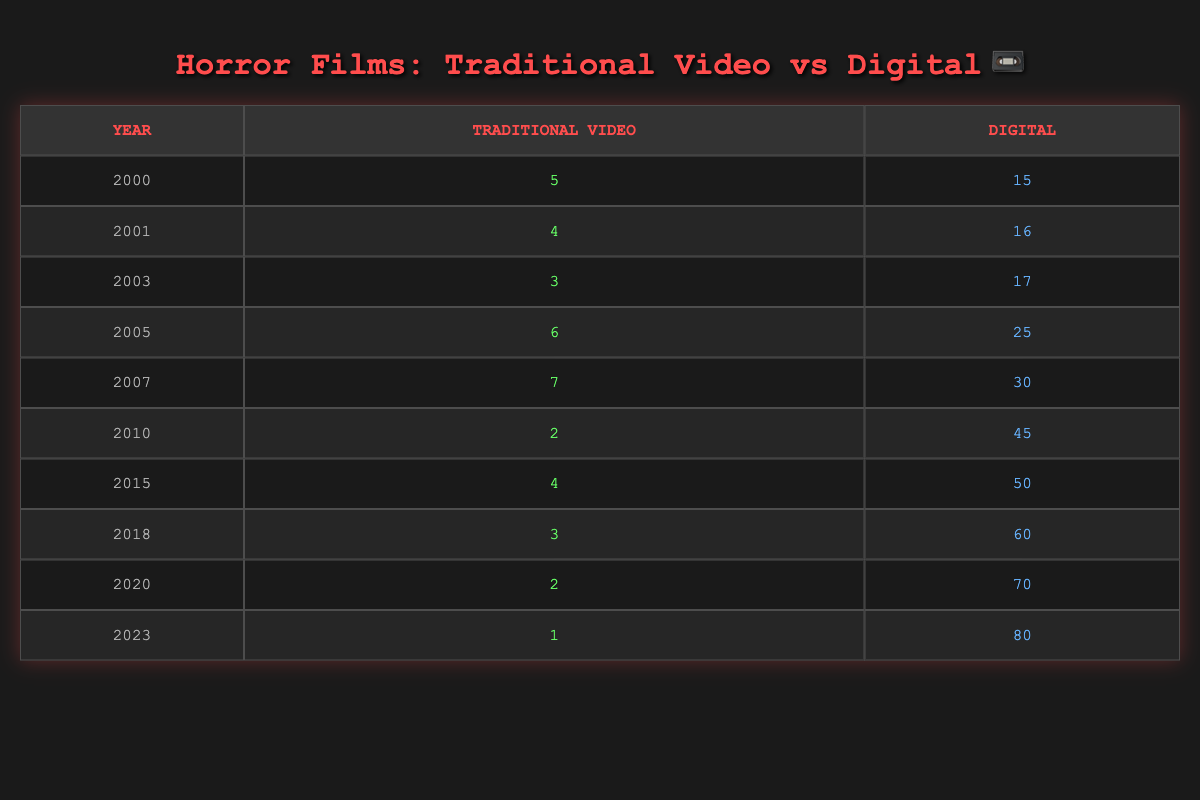What year had the highest number of traditional video horror films? Looking at the "Traditional Video" column, the highest value is 7, which occurs in the year 2007.
Answer: 2007 How many digital horror films were released in total from 2000 to 2023? To find the total, we sum the "Digital" column: 15 + 16 + 17 + 25 + 30 + 45 + 50 + 60 + 70 + 80 = 408.
Answer: 408 Was there an increase or decrease in the number of traditional video films from 2001 to 2005? In 2001, there were 4 traditional video films and in 2005, there were 6. Since 6 is greater than 4, it indicates an increase.
Answer: Increase What is the difference between the number of traditional and digital horror films in the year 2010? In 2010, there were 2 traditional video films and 45 digital films. The difference is 45 - 2 = 43.
Answer: 43 What was the average number of traditional video horror films released per year from 2000 to 2023? To find the average, we first sum the traditional video films: 5 + 4 + 3 + 6 + 7 + 2 + 4 + 3 + 2 + 1 = 37. There are 10 years, so the average is 37 / 10 = 3.7.
Answer: 3.7 Was the number of digital horror films in 2023 greater than the average for digital films from 2000 to 2023? First, we find the average for digital films: (15 + 16 + 17 + 25 + 30 + 45 + 50 + 60 + 70 + 80) / 10 equals 40.8. The 2023 digital films amount to 80, which is greater than 40.8.
Answer: Yes In how many years between 2000 and 2023 did the number of traditional video films exceed 5? The years are 2000 (5), 2005 (6), and 2007 (7). Thus, the count of years is 3.
Answer: 3 What percentage of horror films were shot on traditional video in the year 2018? In 2018, there were 3 traditional video films and 60 digital films. Total films = 3 + 60 = 63. Traditional percentage = (3/63) * 100, which equals approximately 4.76%.
Answer: 4.76% 